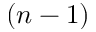<formula> <loc_0><loc_0><loc_500><loc_500>( n - 1 )</formula> 